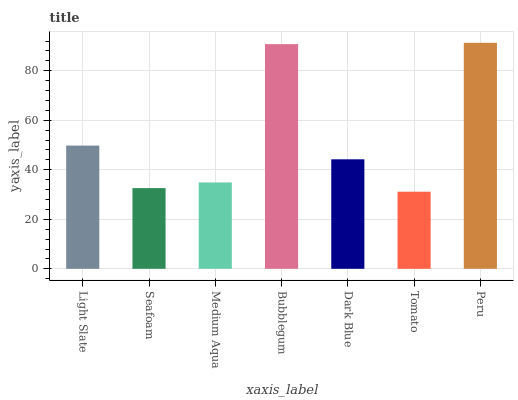Is Seafoam the minimum?
Answer yes or no. No. Is Seafoam the maximum?
Answer yes or no. No. Is Light Slate greater than Seafoam?
Answer yes or no. Yes. Is Seafoam less than Light Slate?
Answer yes or no. Yes. Is Seafoam greater than Light Slate?
Answer yes or no. No. Is Light Slate less than Seafoam?
Answer yes or no. No. Is Dark Blue the high median?
Answer yes or no. Yes. Is Dark Blue the low median?
Answer yes or no. Yes. Is Medium Aqua the high median?
Answer yes or no. No. Is Medium Aqua the low median?
Answer yes or no. No. 